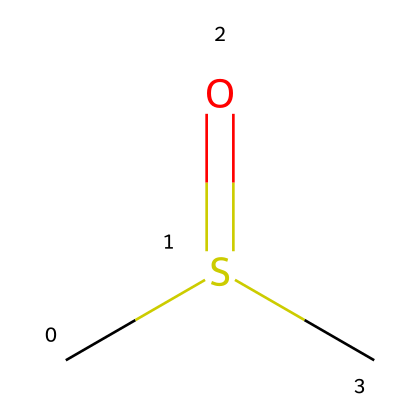what is the molecular formula of this compound? The chemical structure can be analyzed to determine the number of carbon (C), sulfur (S), and oxygen (O) atoms present. This molecule has one carbon atom, one sulfur atom, and two oxygen atoms in its structure. Therefore, the molecular formula is derived as C1H4O2S1, leading to a simplified form of C2H6OS.
Answer: C2H6OS how many carbon atoms are in the chemical structure? By examining the chemical structure, we see one 'C' within the SMILES representation. Therefore, there is a total of one carbon atom in this compound.
Answer: 1 what functional group is present in this organosulfur compound? The presence of the "S(=O)" part of the SMILES indicates the presence of a sulfonyl functional group (-SO2-), which is characteristic of organosulfur compounds.
Answer: sulfonyl is this compound polar or nonpolar? The presence of sulfur and oxygen atoms suggests polar characteristics due to their electronegativities and the ability to create dipole moments in the molecule. Therefore, the overall molecular structure is expected to be polar.
Answer: polar what type of reaction could this organosulfur compound undergo? Organosulfur compounds like this can undergo oxidation or nucleophilic substitution reactions due to their functional groups, particularly involving the sulfur atom. This means it can react with nucleophiles or even oxidants in various chemical processes.
Answer: oxidation how does the presence of sulfur affect the reactivity of this compound? Sulfur's unique properties, including its ability to form strong bonds and attract electrons, increase the reactivity of the compound. The sulfur atom can also facilitate various reactions by acting as a nucleophile or participating in redox reactions, enhancing the compound's overall reactivity.
Answer: increases reactivity 